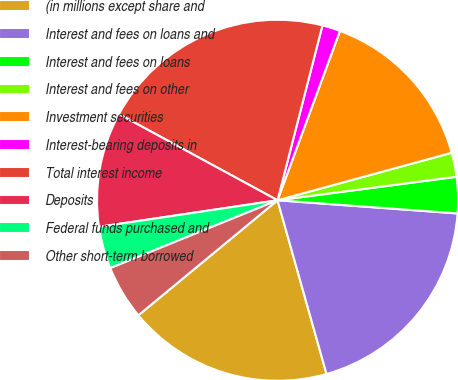<chart> <loc_0><loc_0><loc_500><loc_500><pie_chart><fcel>(in millions except share and<fcel>Interest and fees on loans and<fcel>Interest and fees on loans<fcel>Interest and fees on other<fcel>Investment securities<fcel>Interest-bearing deposits in<fcel>Total interest income<fcel>Deposits<fcel>Federal funds purchased and<fcel>Other short-term borrowed<nl><fcel>18.38%<fcel>19.46%<fcel>3.24%<fcel>2.16%<fcel>15.14%<fcel>1.62%<fcel>21.08%<fcel>10.27%<fcel>3.78%<fcel>4.86%<nl></chart> 